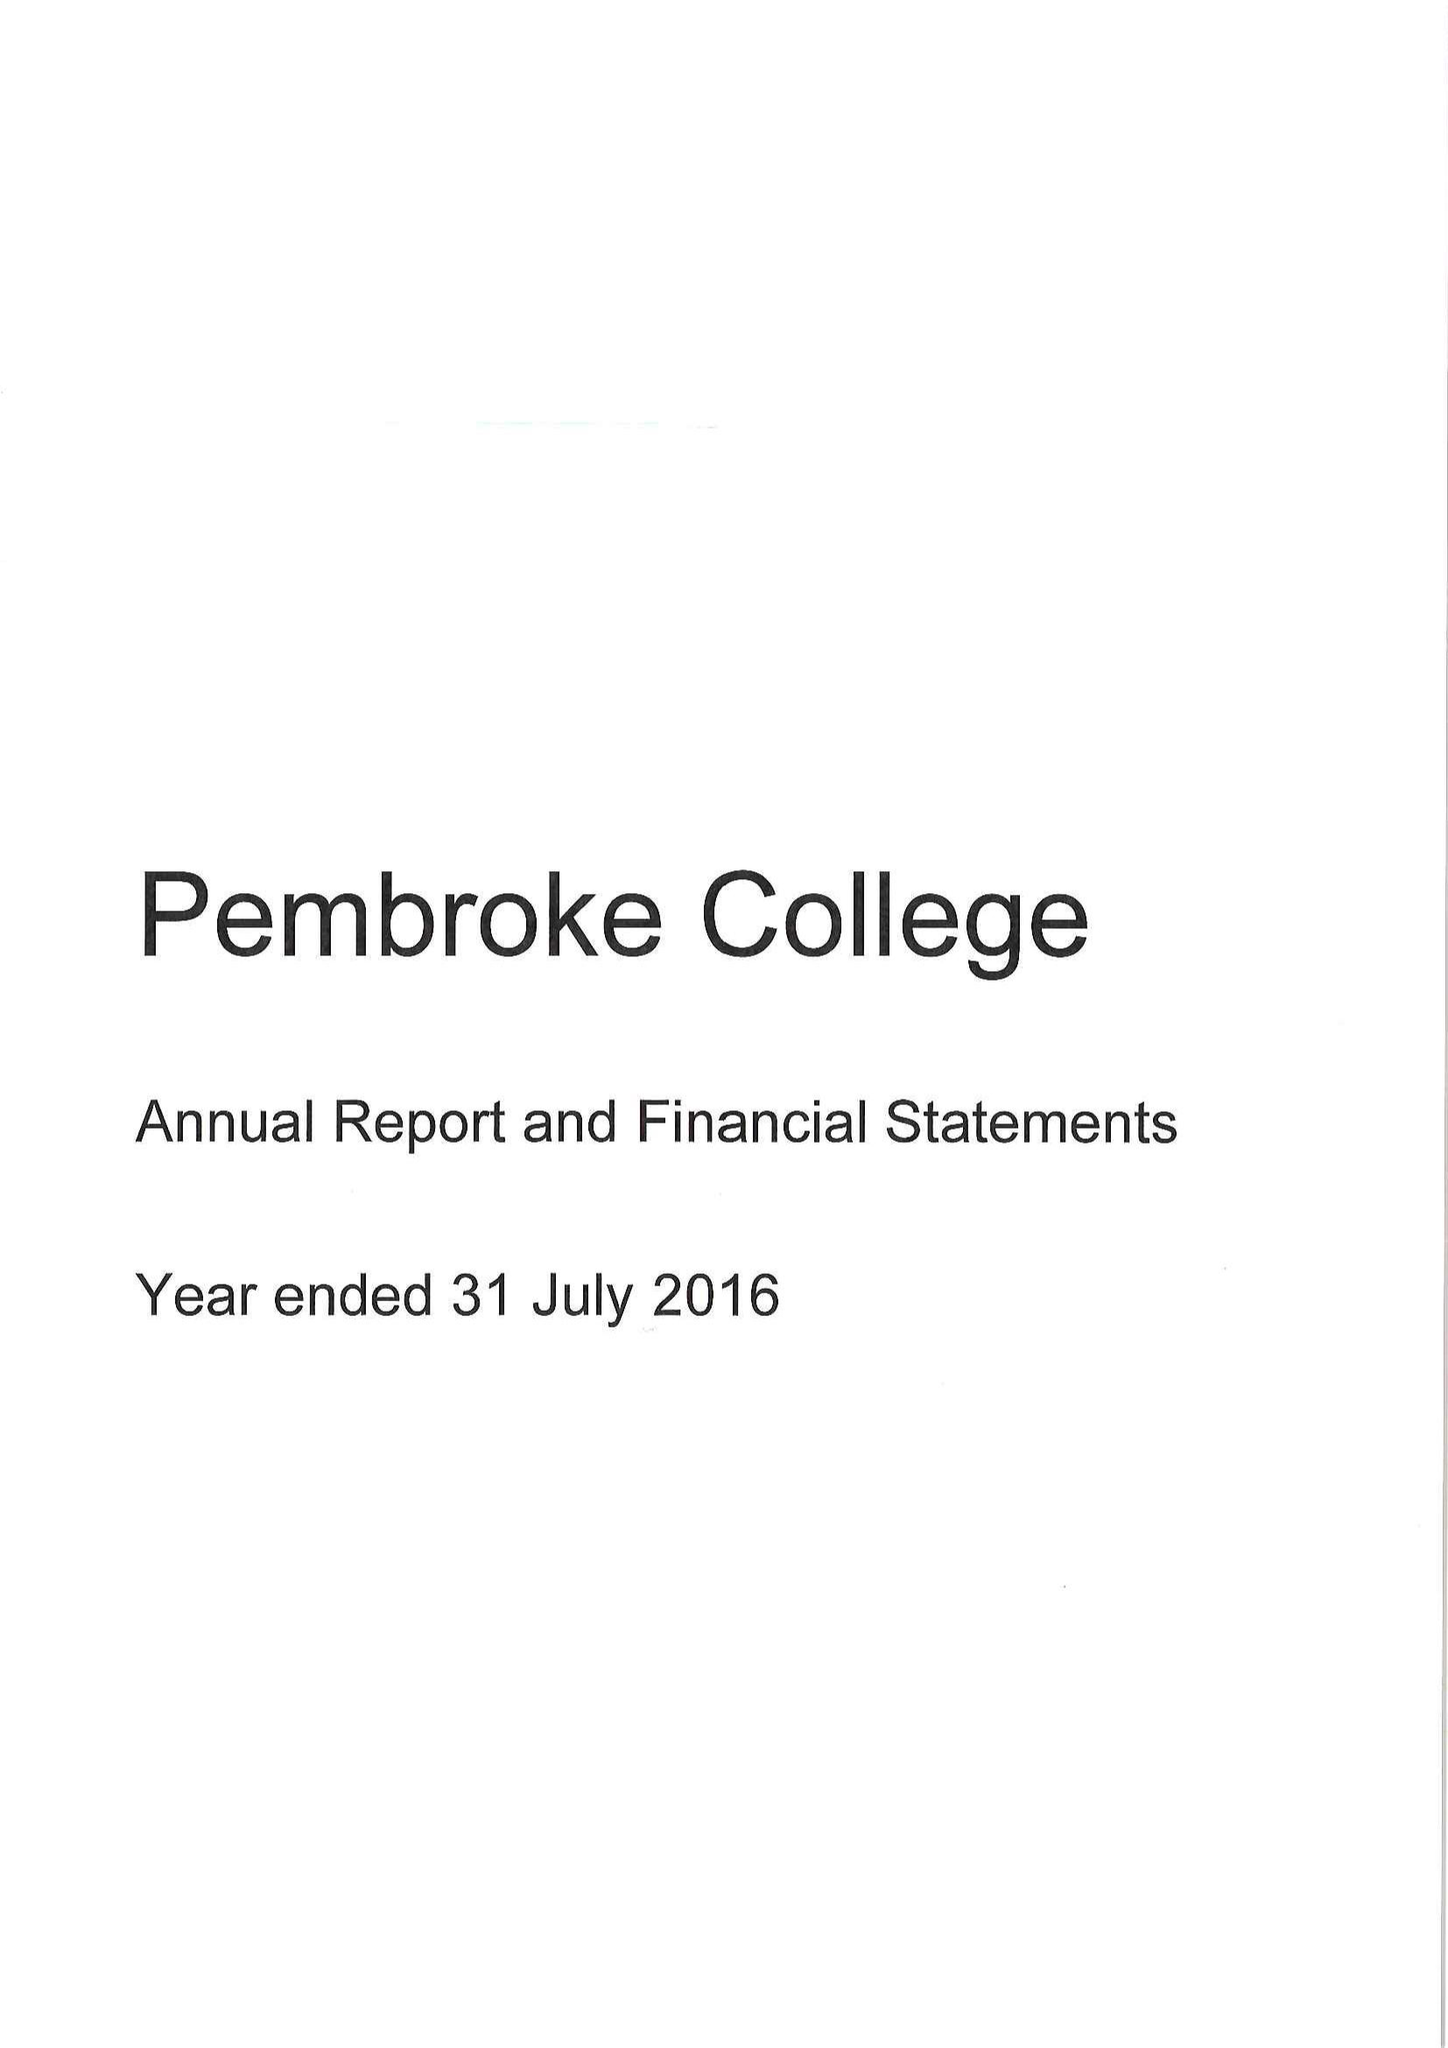What is the value for the report_date?
Answer the question using a single word or phrase. 2016-07-31 